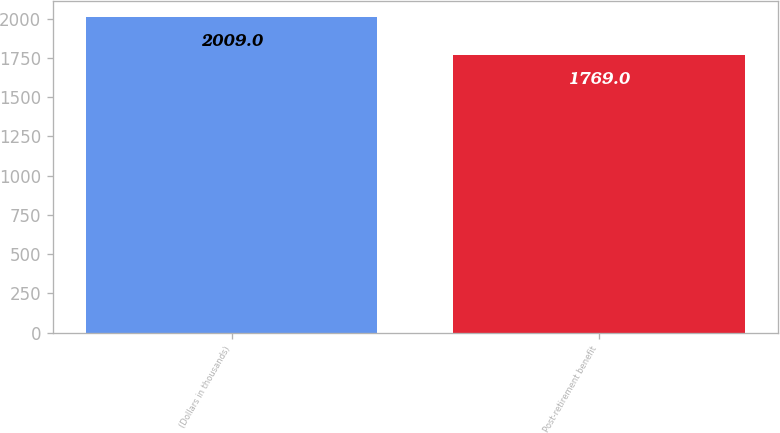Convert chart. <chart><loc_0><loc_0><loc_500><loc_500><bar_chart><fcel>(Dollars in thousands)<fcel>Post-retirement benefit<nl><fcel>2009<fcel>1769<nl></chart> 